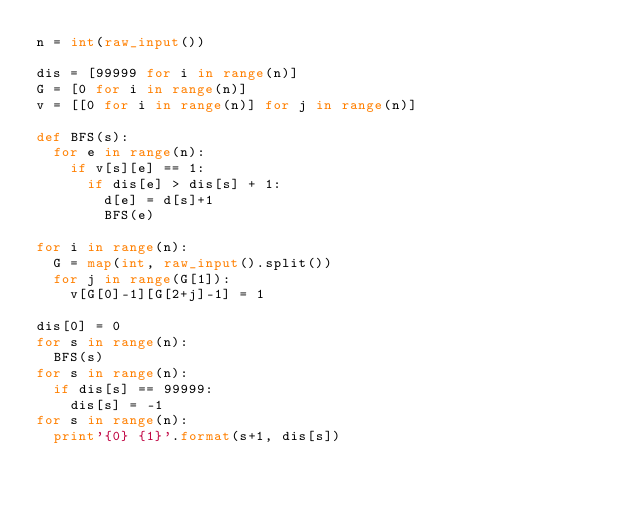Convert code to text. <code><loc_0><loc_0><loc_500><loc_500><_Python_>n = int(raw_input())
   
dis = [99999 for i in range(n)]
G = [0 for i in range(n)]
v = [[0 for i in range(n)] for j in range(n)]
   
def BFS(s):
  for e in range(n):
    if v[s][e] == 1:
      if dis[e] > dis[s] + 1:
        d[e] = d[s]+1
        BFS(e)
   
for i in range(n):
  G = map(int, raw_input().split())
  for j in range(G[1]):
    v[G[0]-1][G[2+j]-1] = 1
   
dis[0] = 0
for s in range(n):
  BFS(s)
for s in range(n):
  if dis[s] == 99999:
    dis[s] = -1
for s in range(n):
  print'{0} {1}'.format(s+1, dis[s])</code> 